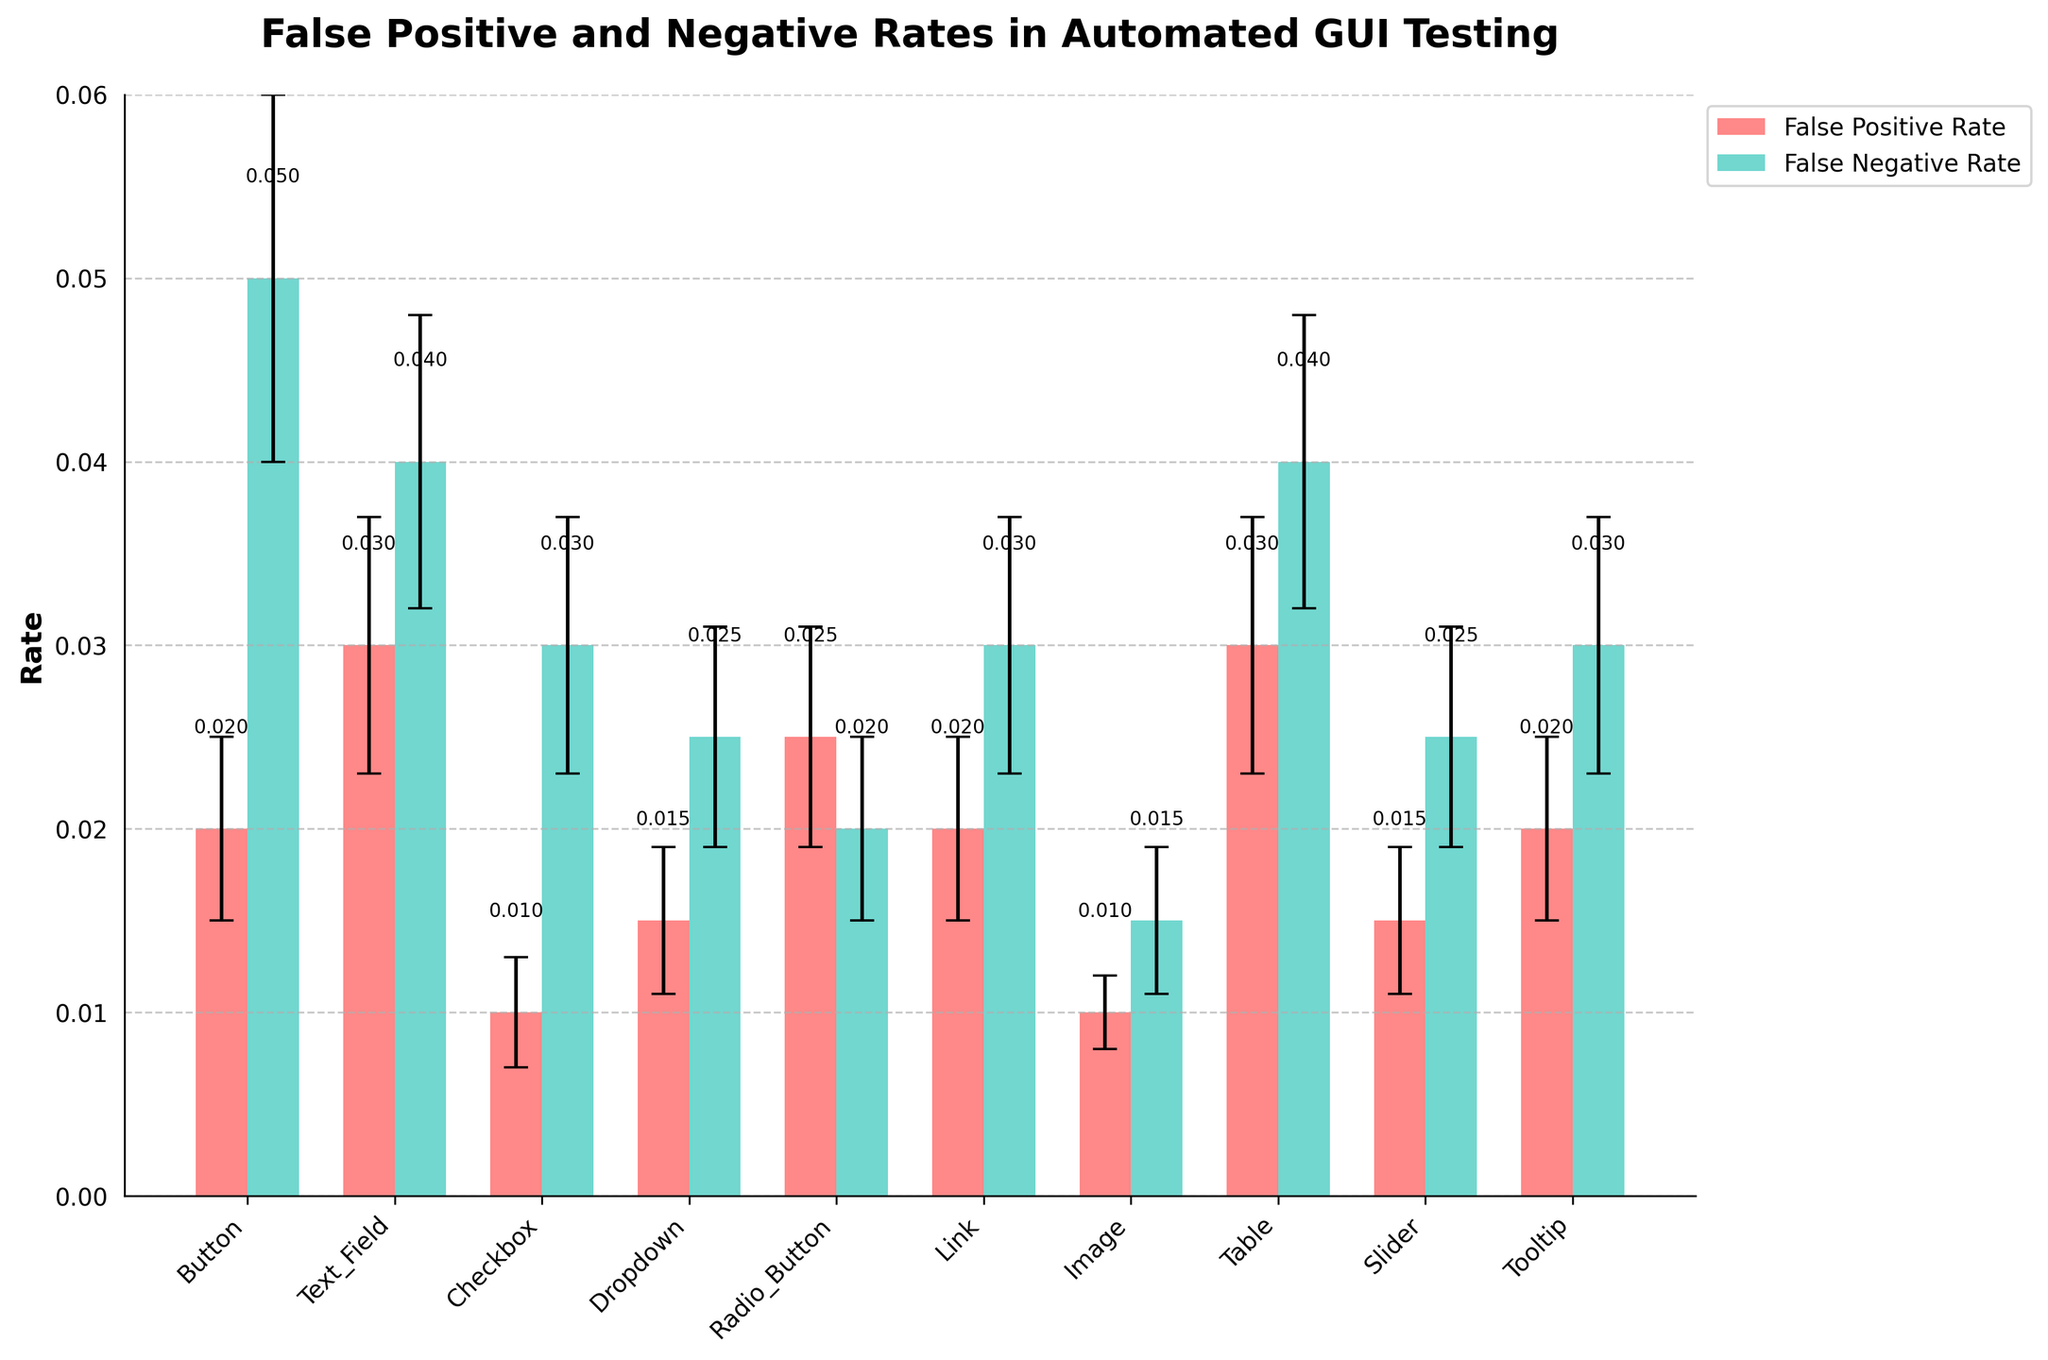Which web element has the highest false positive rate? Observing the heights of the red bars representing the false positive rates, the Table element has the highest bar.
Answer: Table What is the difference between the false positive and false negative rates for the Checkbox element? The false positive rate for Checkbox is 0.01 and the false negative rate is 0.03. Subtracting the two gives 0.03 - 0.01 = 0.02.
Answer: 0.02 Among the Button, Link, and Tooltip elements, which has the lowest false negative rate? Comparing the heights of the green bars for Button (0.05), Link (0.03), and Tooltip (0.03), the Button has the highest rate, while both Link and Tooltip share the same lowest rate.
Answer: Link and Tooltip How does the false positive rate of the Image element compare to the false negative rate of the Radio Button element? The false positive rate of the Image is 0.01, and the false negative rate of the Radio Button is 0.02. By comparing, 0.01 < 0.02.
Answer: Less than What do the error bars represent in this figure? The error bars depict the error margins for each respective false positive and false negative rate, providing a sense of statistical uncertainty or variability.
Answer: Error margins What is the average false positive rate of the elements shown? Summing up all the false positive rates (0.02 + 0.03 + 0.01 + 0.015 + 0.025 + 0.02 + 0.01 + 0.03 + 0.015 + 0.02) gives 0.195. Dividing by the number of elements (10) gives an average of 0.195 / 10 = 0.0195.
Answer: 0.0195 Which element has the largest error margin for the false positive rate? The segment of the dataset showing the error margins indicates that the Text_Field and Table elements have the largest error margins for false positive rates at 0.007.
Answer: Text_Field and Table If the error margin for the false positive rate of the Button element was reduced to 0.002, how would that compare to the current error margin of the Image element? If the Button's error margin is reduced to 0.002, it would be similar to the current error margin of the Image element, which is also 0.002.
Answer: Same Why is it useful to include both false positive and false negative rates in this analysis? Including both false positive and false negative rates gives a more comprehensive view of testing performance. It shows both incorrect positive detections and missed detections, highlighting areas that may need improvement.
Answer: Comprehensive view of testing performance 